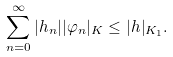Convert formula to latex. <formula><loc_0><loc_0><loc_500><loc_500>\sum _ { n = 0 } ^ { \infty } | h _ { n } | | \varphi _ { n } | _ { K } \leq | h | _ { K _ { 1 } } .</formula> 